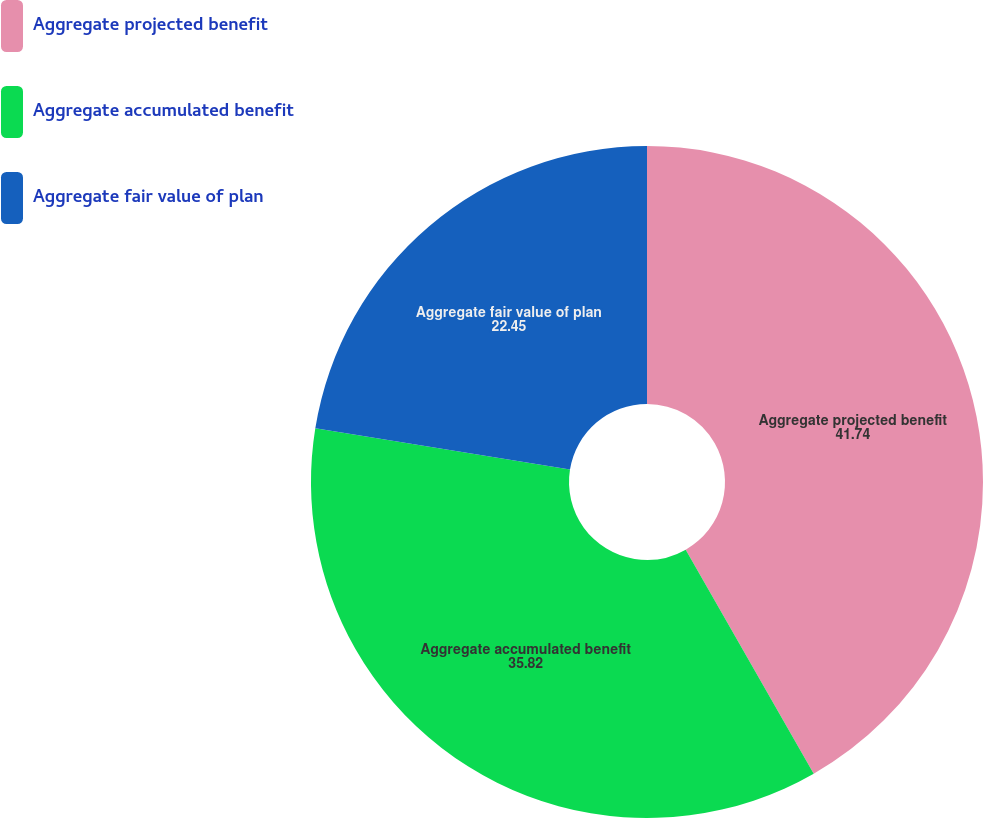Convert chart to OTSL. <chart><loc_0><loc_0><loc_500><loc_500><pie_chart><fcel>Aggregate projected benefit<fcel>Aggregate accumulated benefit<fcel>Aggregate fair value of plan<nl><fcel>41.74%<fcel>35.82%<fcel>22.45%<nl></chart> 